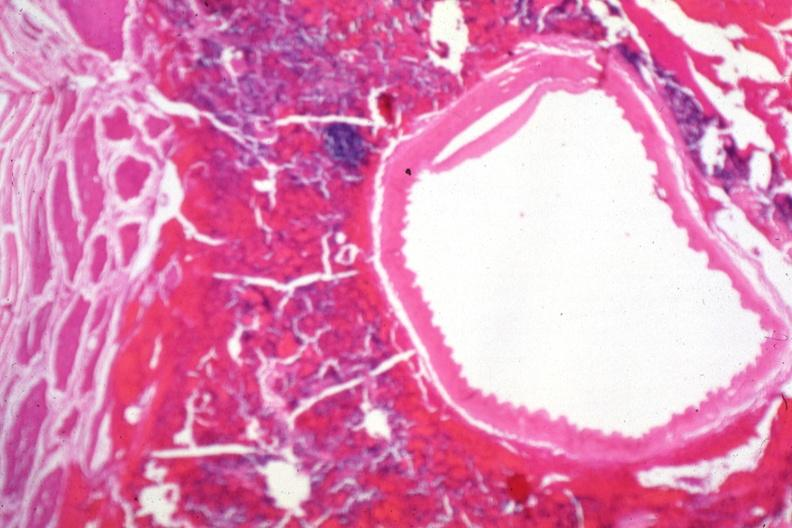how does this image show carotid artery near sella?
Answer the question using a single word or phrase. With tumor cells in soft tissue 